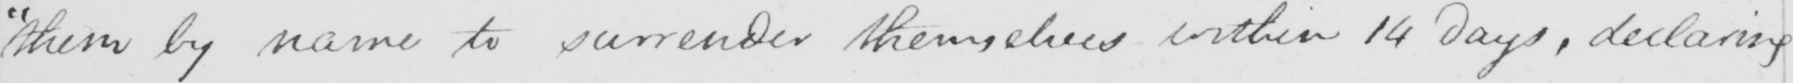What does this handwritten line say? "them by name to surrender themselves within 14 days, declaring 